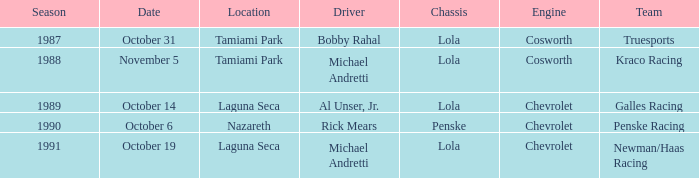When did the race at nazareth take place? October 6. 